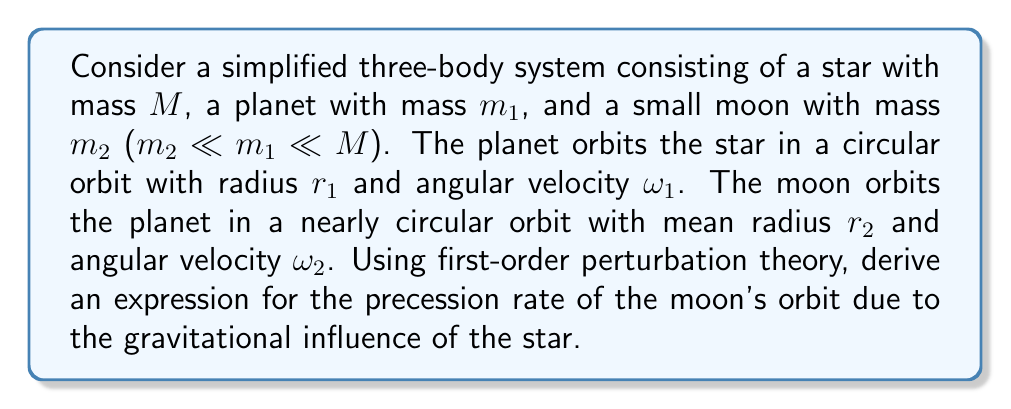Can you answer this question? 1) First, we set up the problem in a rotating reference frame that orbits with the planet around the star. In this frame, the star and planet are stationary, and we focus on the moon's motion.

2) The effective potential for the moon in this rotating frame is:

   $$V_{eff} = -\frac{GM}{|\vec{r} + \vec{r_1}|} - \frac{Gm_1}{r} - \frac{1}{2}\omega_1^2(x^2 + y^2)$$

   where $\vec{r}$ is the moon's position relative to the planet, and $\vec{r_1}$ is the planet's position relative to the star.

3) Expand this potential in powers of $r/r_1$, keeping terms up to second order:

   $$V_{eff} \approx -\frac{GM}{r_1} - \frac{Gm_1}{r} - \frac{1}{2}\omega_1^2r_1^2 + \frac{GM}{2r_1^3}(x^2 + y^2 - 2z^2) - \frac{1}{2}\omega_1^2(x^2 + y^2)$$

4) The last two terms represent the perturbation to the moon's orbit. We can simplify using Kepler's third law for the planet's orbit: $\omega_1^2 = GM/r_1^3$

   $$V_{perturb} = \frac{GM}{2r_1^3}(x^2 + y^2 - 2z^2) - \frac{GM}{2r_1^3}(x^2 + y^2) = -\frac{3GM}{2r_1^3}z^2$$

5) This perturbation has the form of a quadrupole moment. The effect on the orbit can be calculated using the standard results from perturbation theory for central force problems.

6) The precession rate of the orbital plane (nodal precession) due to a quadrupole moment is given by:

   $$\Omega = -\frac{3}{4}\frac{J_2}{\omega_2 r_2^2}$$

   where $J_2$ is the quadrupole moment coefficient.

7) In our case, $J_2 = GMr_2^2/r_1^3$, so the precession rate is:

   $$\Omega = -\frac{3}{4}\frac{GM}{\omega_2 r_1^3}$$

8) We can express $\omega_2$ in terms of $r_2$ using Kepler's third law for the moon's orbit around the planet:

   $$\omega_2^2 = \frac{Gm_1}{r_2^3}$$

9) Substituting this into our expression for $\Omega$:

   $$\Omega = -\frac{3}{4}\sqrt{\frac{Gm_1}{r_2^3}}\frac{M}{m_1}\left(\frac{r_2}{r_1}\right)^3$$

This is the precession rate of the moon's orbit due to the star's gravitational influence.
Answer: $$\Omega = -\frac{3}{4}\sqrt{\frac{Gm_1}{r_2^3}}\frac{M}{m_1}\left(\frac{r_2}{r_1}\right)^3$$ 